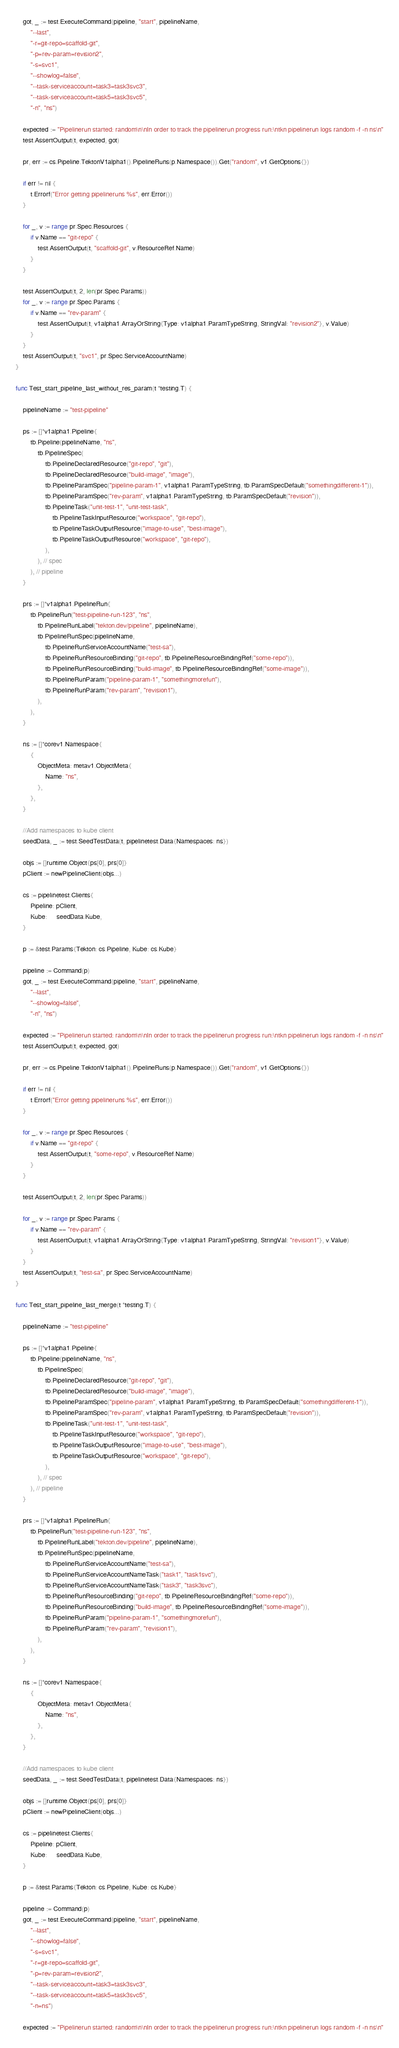Convert code to text. <code><loc_0><loc_0><loc_500><loc_500><_Go_>	got, _ := test.ExecuteCommand(pipeline, "start", pipelineName,
		"--last",
		"-r=git-repo=scaffold-git",
		"-p=rev-param=revision2",
		"-s=svc1",
		"--showlog=false",
		"--task-serviceaccount=task3=task3svc3",
		"--task-serviceaccount=task5=task3svc5",
		"-n", "ns")

	expected := "Pipelinerun started: random\n\nIn order to track the pipelinerun progress run:\ntkn pipelinerun logs random -f -n ns\n"
	test.AssertOutput(t, expected, got)

	pr, err := cs.Pipeline.TektonV1alpha1().PipelineRuns(p.Namespace()).Get("random", v1.GetOptions{})

	if err != nil {
		t.Errorf("Error getting pipelineruns %s", err.Error())
	}

	for _, v := range pr.Spec.Resources {
		if v.Name == "git-repo" {
			test.AssertOutput(t, "scaffold-git", v.ResourceRef.Name)
		}
	}

	test.AssertOutput(t, 2, len(pr.Spec.Params))
	for _, v := range pr.Spec.Params {
		if v.Name == "rev-param" {
			test.AssertOutput(t, v1alpha1.ArrayOrString{Type: v1alpha1.ParamTypeString, StringVal: "revision2"}, v.Value)
		}
	}
	test.AssertOutput(t, "svc1", pr.Spec.ServiceAccountName)
}

func Test_start_pipeline_last_without_res_param(t *testing.T) {

	pipelineName := "test-pipeline"

	ps := []*v1alpha1.Pipeline{
		tb.Pipeline(pipelineName, "ns",
			tb.PipelineSpec(
				tb.PipelineDeclaredResource("git-repo", "git"),
				tb.PipelineDeclaredResource("build-image", "image"),
				tb.PipelineParamSpec("pipeline-param-1", v1alpha1.ParamTypeString, tb.ParamSpecDefault("somethingdifferent-1")),
				tb.PipelineParamSpec("rev-param", v1alpha1.ParamTypeString, tb.ParamSpecDefault("revision")),
				tb.PipelineTask("unit-test-1", "unit-test-task",
					tb.PipelineTaskInputResource("workspace", "git-repo"),
					tb.PipelineTaskOutputResource("image-to-use", "best-image"),
					tb.PipelineTaskOutputResource("workspace", "git-repo"),
				),
			), // spec
		), // pipeline
	}

	prs := []*v1alpha1.PipelineRun{
		tb.PipelineRun("test-pipeline-run-123", "ns",
			tb.PipelineRunLabel("tekton.dev/pipeline", pipelineName),
			tb.PipelineRunSpec(pipelineName,
				tb.PipelineRunServiceAccountName("test-sa"),
				tb.PipelineRunResourceBinding("git-repo", tb.PipelineResourceBindingRef("some-repo")),
				tb.PipelineRunResourceBinding("build-image", tb.PipelineResourceBindingRef("some-image")),
				tb.PipelineRunParam("pipeline-param-1", "somethingmorefun"),
				tb.PipelineRunParam("rev-param", "revision1"),
			),
		),
	}

	ns := []*corev1.Namespace{
		{
			ObjectMeta: metav1.ObjectMeta{
				Name: "ns",
			},
		},
	}

	//Add namespaces to kube client
	seedData, _ := test.SeedTestData(t, pipelinetest.Data{Namespaces: ns})

	objs := []runtime.Object{ps[0], prs[0]}
	pClient := newPipelineClient(objs...)

	cs := pipelinetest.Clients{
		Pipeline: pClient,
		Kube:     seedData.Kube,
	}

	p := &test.Params{Tekton: cs.Pipeline, Kube: cs.Kube}

	pipeline := Command(p)
	got, _ := test.ExecuteCommand(pipeline, "start", pipelineName,
		"--last",
		"--showlog=false",
		"-n", "ns")

	expected := "Pipelinerun started: random\n\nIn order to track the pipelinerun progress run:\ntkn pipelinerun logs random -f -n ns\n"
	test.AssertOutput(t, expected, got)

	pr, err := cs.Pipeline.TektonV1alpha1().PipelineRuns(p.Namespace()).Get("random", v1.GetOptions{})

	if err != nil {
		t.Errorf("Error getting pipelineruns %s", err.Error())
	}

	for _, v := range pr.Spec.Resources {
		if v.Name == "git-repo" {
			test.AssertOutput(t, "some-repo", v.ResourceRef.Name)
		}
	}

	test.AssertOutput(t, 2, len(pr.Spec.Params))

	for _, v := range pr.Spec.Params {
		if v.Name == "rev-param" {
			test.AssertOutput(t, v1alpha1.ArrayOrString{Type: v1alpha1.ParamTypeString, StringVal: "revision1"}, v.Value)
		}
	}
	test.AssertOutput(t, "test-sa", pr.Spec.ServiceAccountName)
}

func Test_start_pipeline_last_merge(t *testing.T) {

	pipelineName := "test-pipeline"

	ps := []*v1alpha1.Pipeline{
		tb.Pipeline(pipelineName, "ns",
			tb.PipelineSpec(
				tb.PipelineDeclaredResource("git-repo", "git"),
				tb.PipelineDeclaredResource("build-image", "image"),
				tb.PipelineParamSpec("pipeline-param", v1alpha1.ParamTypeString, tb.ParamSpecDefault("somethingdifferent-1")),
				tb.PipelineParamSpec("rev-param", v1alpha1.ParamTypeString, tb.ParamSpecDefault("revision")),
				tb.PipelineTask("unit-test-1", "unit-test-task",
					tb.PipelineTaskInputResource("workspace", "git-repo"),
					tb.PipelineTaskOutputResource("image-to-use", "best-image"),
					tb.PipelineTaskOutputResource("workspace", "git-repo"),
				),
			), // spec
		), // pipeline
	}

	prs := []*v1alpha1.PipelineRun{
		tb.PipelineRun("test-pipeline-run-123", "ns",
			tb.PipelineRunLabel("tekton.dev/pipeline", pipelineName),
			tb.PipelineRunSpec(pipelineName,
				tb.PipelineRunServiceAccountName("test-sa"),
				tb.PipelineRunServiceAccountNameTask("task1", "task1svc"),
				tb.PipelineRunServiceAccountNameTask("task3", "task3svc"),
				tb.PipelineRunResourceBinding("git-repo", tb.PipelineResourceBindingRef("some-repo")),
				tb.PipelineRunResourceBinding("build-image", tb.PipelineResourceBindingRef("some-image")),
				tb.PipelineRunParam("pipeline-param-1", "somethingmorefun"),
				tb.PipelineRunParam("rev-param", "revision1"),
			),
		),
	}

	ns := []*corev1.Namespace{
		{
			ObjectMeta: metav1.ObjectMeta{
				Name: "ns",
			},
		},
	}

	//Add namespaces to kube client
	seedData, _ := test.SeedTestData(t, pipelinetest.Data{Namespaces: ns})

	objs := []runtime.Object{ps[0], prs[0]}
	pClient := newPipelineClient(objs...)

	cs := pipelinetest.Clients{
		Pipeline: pClient,
		Kube:     seedData.Kube,
	}

	p := &test.Params{Tekton: cs.Pipeline, Kube: cs.Kube}

	pipeline := Command(p)
	got, _ := test.ExecuteCommand(pipeline, "start", pipelineName,
		"--last",
		"--showlog=false",
		"-s=svc1",
		"-r=git-repo=scaffold-git",
		"-p=rev-param=revision2",
		"--task-serviceaccount=task3=task3svc3",
		"--task-serviceaccount=task5=task3svc5",
		"-n=ns")

	expected := "Pipelinerun started: random\n\nIn order to track the pipelinerun progress run:\ntkn pipelinerun logs random -f -n ns\n"</code> 